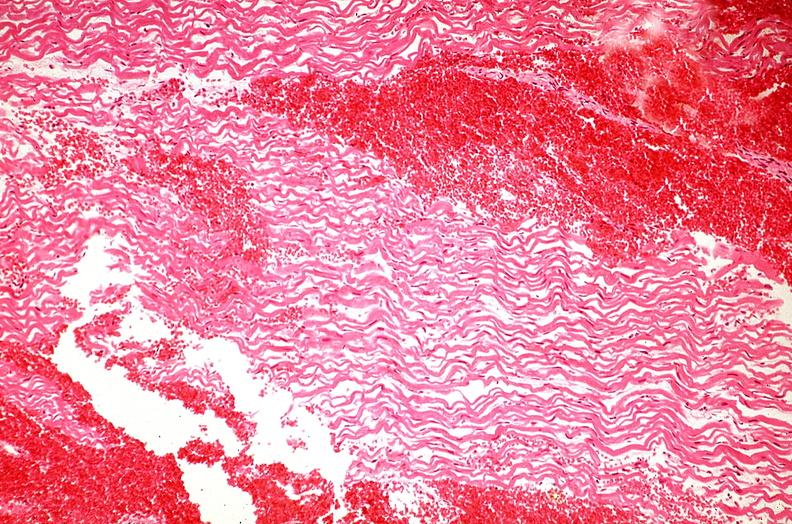s liver present?
Answer the question using a single word or phrase. No 